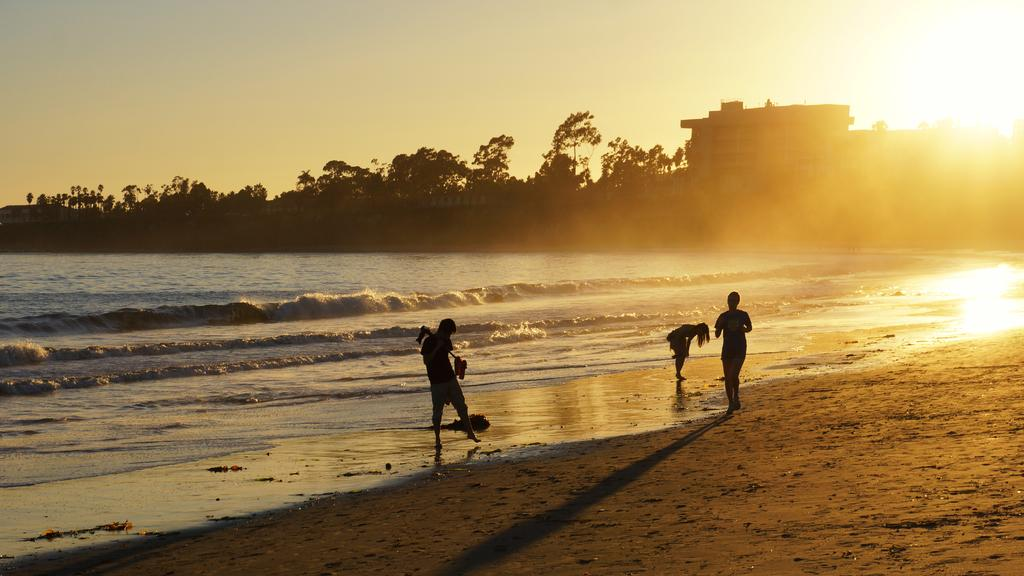How many people are standing on the sand in the foreground? There are three people standing on the sand in the foreground. What can be seen in the background of the image? In the background, there is water, trees, buildings, the sun, and the sky visible. What type of natural environment is present in the image? The natural environment in the image includes sand and water. What type of structures can be seen in the background? Buildings can be seen in the background of the image. What type of wrench is being used by one of the people in the image? There is no wrench present in the image; the people are standing on the sand and not using any tools. How many boats are visible in the image? There are no boats visible in the image; it features people standing on the sand and various elements in the background. 